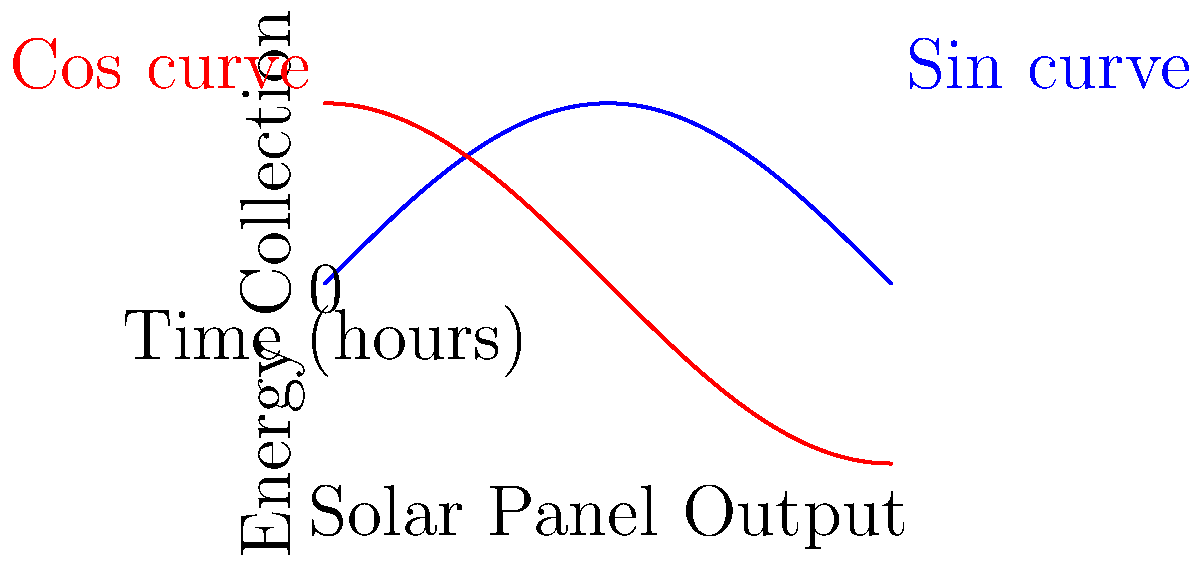A solar panel array's energy collection throughout the day can be modeled by the function $E(\theta) = A \sin(\theta) + B \cos(\theta)$, where $\theta$ represents the time of day in radians (0 to $\pi$), and $A$ and $B$ are constants. To maximize energy collection, we need to find the optimal angle for the array. What is the formula for the optimal angle $\theta_{max}$ in terms of $A$ and $B$? To find the optimal angle, we need to maximize the function $E(\theta)$. Let's approach this step-by-step:

1) First, we take the derivative of $E(\theta)$ with respect to $\theta$:
   $$\frac{dE}{d\theta} = A \cos(\theta) - B \sin(\theta)$$

2) To find the maximum, we set this derivative equal to zero:
   $$A \cos(\theta) - B \sin(\theta) = 0$$

3) Rearrange the equation:
   $$A \cos(\theta) = B \sin(\theta)$$

4) Divide both sides by $\cos(\theta)$ (assuming $\cos(\theta) \neq 0$):
   $$A = B \tan(\theta)$$

5) Now, solve for $\theta$:
   $$\theta = \arctan(\frac{A}{B})$$

6) However, $\arctan$ only gives values between $-\frac{\pi}{2}$ and $\frac{\pi}{2}$. To account for all possible values of $A$ and $B$, we need to use the two-argument arctangent function, $\text{atan2}(y, x)$, which considers the signs of both arguments to determine the correct quadrant.

Therefore, the optimal angle $\theta_{max}$ is given by:
$$\theta_{max} = \text{atan2}(A, B)$$

This formula ensures that we get the correct angle regardless of whether $A$ or $B$ is negative.
Answer: $\theta_{max} = \text{atan2}(A, B)$ 